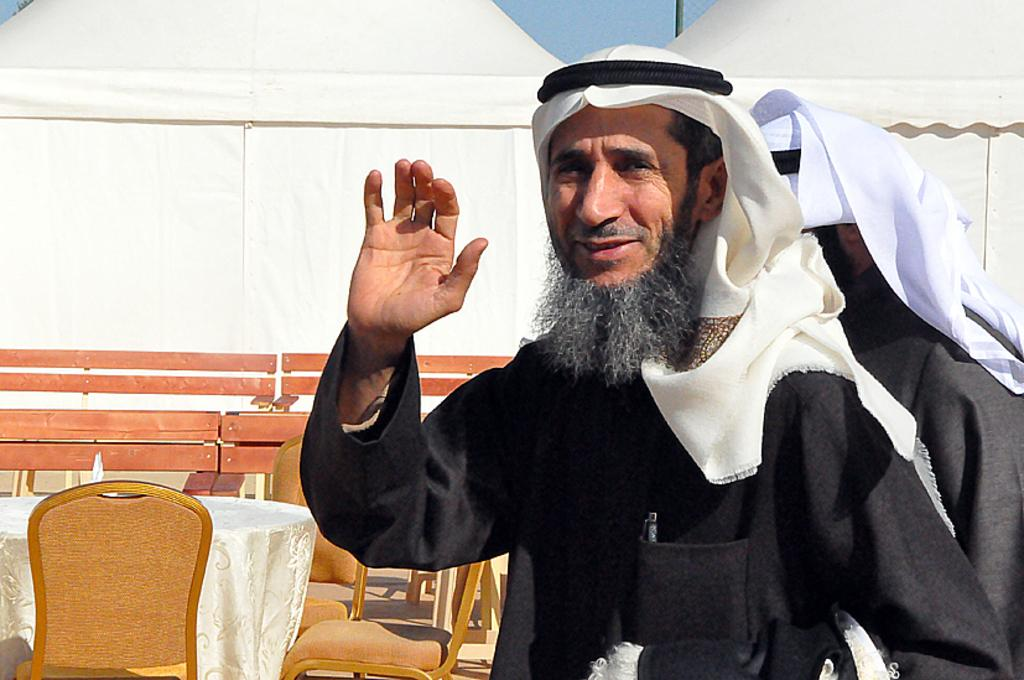What is the man in the image doing with his hand? The man is raising his hand in the image. What is the man standing near in the image? There is a table in the image. What is on the ground in the image? There are chairs on the ground in the image. Can you describe the position of the person at the back of the image? There is a person standing at the back of the image. What type of vein is visible on the man's hand in the image? There is no vein visible on the man's hand in the image. How is the glue being used in the image? There is no glue present in the image. 